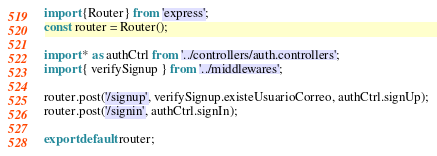Convert code to text. <code><loc_0><loc_0><loc_500><loc_500><_JavaScript_>import {Router} from 'express';
const router = Router();

import * as authCtrl from '../controllers/auth.controllers';
import { verifySignup } from '../middlewares';

router.post('/signup', verifySignup.existeUsuarioCorreo, authCtrl.signUp);
router.post('/signin', authCtrl.signIn);

export default router;</code> 